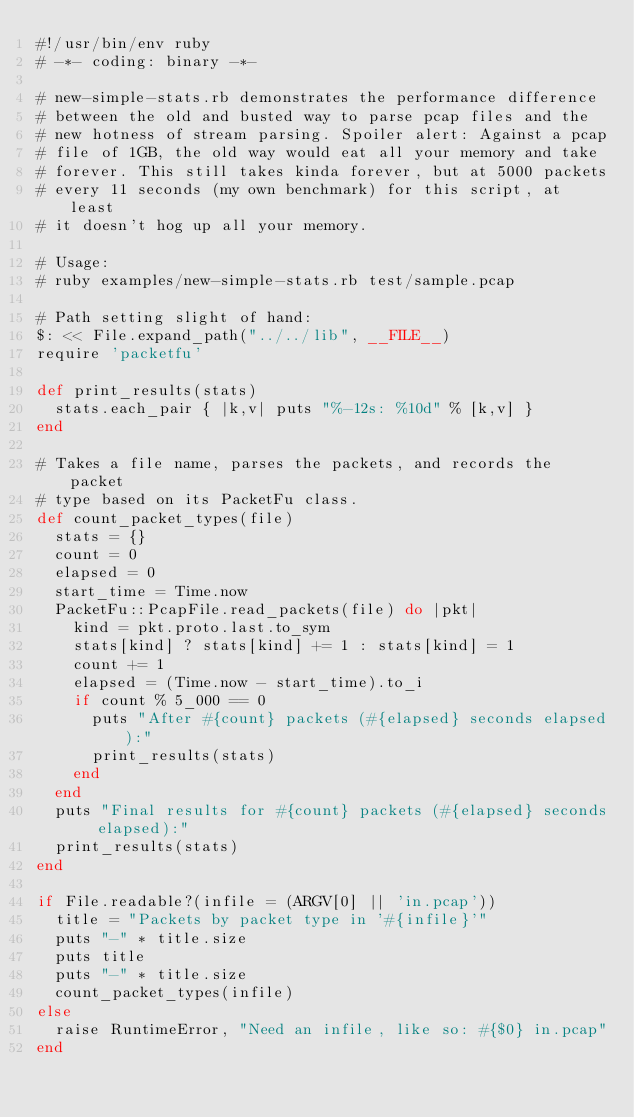Convert code to text. <code><loc_0><loc_0><loc_500><loc_500><_Ruby_>#!/usr/bin/env ruby
# -*- coding: binary -*-

# new-simple-stats.rb demonstrates the performance difference
# between the old and busted way to parse pcap files and the
# new hotness of stream parsing. Spoiler alert: Against a pcap
# file of 1GB, the old way would eat all your memory and take
# forever. This still takes kinda forever, but at 5000 packets
# every 11 seconds (my own benchmark) for this script, at least
# it doesn't hog up all your memory.

# Usage:
# ruby examples/new-simple-stats.rb test/sample.pcap

# Path setting slight of hand:
$: << File.expand_path("../../lib", __FILE__)
require 'packetfu'

def print_results(stats)
  stats.each_pair { |k,v| puts "%-12s: %10d" % [k,v] }
end

# Takes a file name, parses the packets, and records the packet
# type based on its PacketFu class.
def count_packet_types(file)
  stats = {}
  count = 0
  elapsed = 0
  start_time = Time.now
  PacketFu::PcapFile.read_packets(file) do |pkt|
    kind = pkt.proto.last.to_sym
    stats[kind] ? stats[kind] += 1 : stats[kind] = 1
    count += 1
    elapsed = (Time.now - start_time).to_i
    if count % 5_000 == 0
      puts "After #{count} packets (#{elapsed} seconds elapsed):"
      print_results(stats)
    end
  end
  puts "Final results for #{count} packets (#{elapsed} seconds elapsed):"
  print_results(stats)
end

if File.readable?(infile = (ARGV[0] || 'in.pcap'))
  title = "Packets by packet type in '#{infile}'"
  puts "-" * title.size
  puts title
  puts "-" * title.size
  count_packet_types(infile)
else
  raise RuntimeError, "Need an infile, like so: #{$0} in.pcap"
end
</code> 